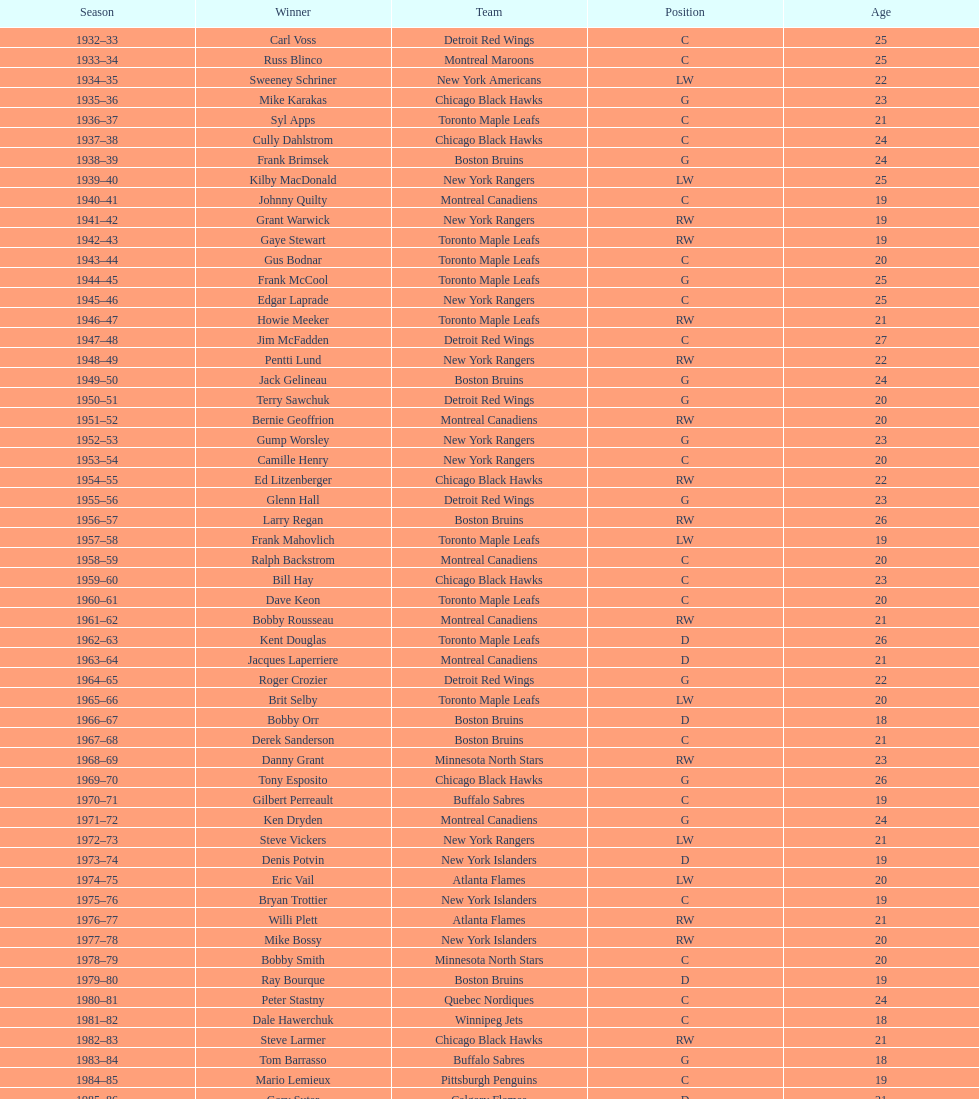Who was the first calder memorial trophy winner from the boston bruins? Frank Brimsek. 